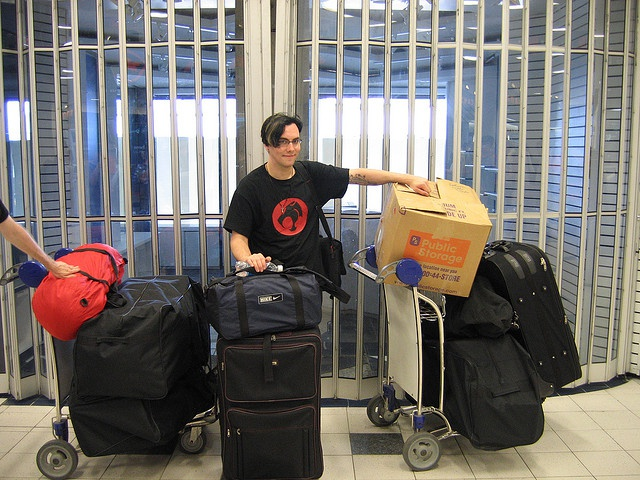Describe the objects in this image and their specific colors. I can see suitcase in black and gray tones, people in black, tan, and gray tones, suitcase in black and gray tones, suitcase in black and gray tones, and suitcase in black, gray, and darkgreen tones in this image. 